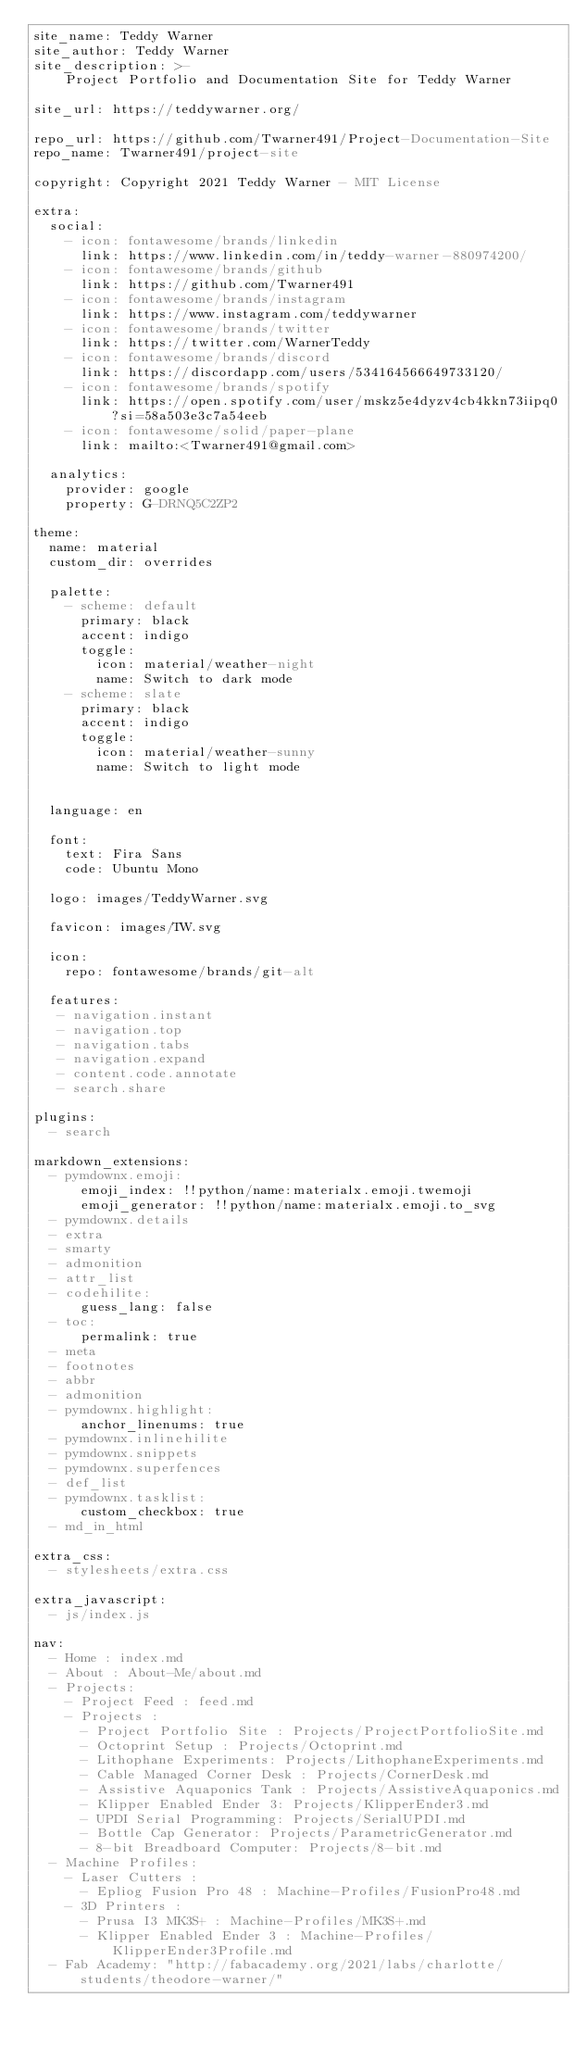Convert code to text. <code><loc_0><loc_0><loc_500><loc_500><_YAML_>site_name: Teddy Warner
site_author: Teddy Warner
site_description: >-
    Project Portfolio and Documentation Site for Teddy Warner

site_url: https://teddywarner.org/

repo_url: https://github.com/Twarner491/Project-Documentation-Site
repo_name: Twarner491/project-site

copyright: Copyright 2021 Teddy Warner - MIT License

extra:
  social:
    - icon: fontawesome/brands/linkedin
      link: https://www.linkedin.com/in/teddy-warner-880974200/
    - icon: fontawesome/brands/github
      link: https://github.com/Twarner491
    - icon: fontawesome/brands/instagram
      link: https://www.instagram.com/teddywarner
    - icon: fontawesome/brands/twitter
      link: https://twitter.com/WarnerTeddy
    - icon: fontawesome/brands/discord
      link: https://discordapp.com/users/534164566649733120/
    - icon: fontawesome/brands/spotify
      link: https://open.spotify.com/user/mskz5e4dyzv4cb4kkn73iipq0?si=58a503e3c7a54eeb
    - icon: fontawesome/solid/paper-plane
      link: mailto:<Twarner491@gmail.com>

  analytics:
    provider: google
    property: G-DRNQ5C2ZP2

theme:
  name: material
  custom_dir: overrides

  palette:
    - scheme: default
      primary: black
      accent: indigo
      toggle:
        icon: material/weather-night
        name: Switch to dark mode
    - scheme: slate
      primary: black
      accent: indigo
      toggle:
        icon: material/weather-sunny
        name: Switch to light mode


  language: en

  font:
    text: Fira Sans
    code: Ubuntu Mono

  logo: images/TeddyWarner.svg

  favicon: images/TW.svg

  icon:
    repo: fontawesome/brands/git-alt
                          
  features:
   - navigation.instant
   - navigation.top
   - navigation.tabs
   - navigation.expand
   - content.code.annotate
   - search.share

plugins:
  - search

markdown_extensions:
  - pymdownx.emoji:
      emoji_index: !!python/name:materialx.emoji.twemoji
      emoji_generator: !!python/name:materialx.emoji.to_svg
  - pymdownx.details
  - extra
  - smarty
  - admonition
  - attr_list
  - codehilite:
      guess_lang: false
  - toc:
      permalink: true
  - meta
  - footnotes
  - abbr
  - admonition
  - pymdownx.highlight:
      anchor_linenums: true
  - pymdownx.inlinehilite
  - pymdownx.snippets
  - pymdownx.superfences
  - def_list
  - pymdownx.tasklist:
      custom_checkbox: true
  - md_in_html

extra_css:
  - stylesheets/extra.css

extra_javascript:
  - js/index.js 

nav:
  - Home : index.md
  - About : About-Me/about.md
  - Projects: 
    - Project Feed : feed.md
    - Projects : 
      - Project Portfolio Site : Projects/ProjectPortfolioSite.md
      - Octoprint Setup : Projects/Octoprint.md
      - Lithophane Experiments: Projects/LithophaneExperiments.md
      - Cable Managed Corner Desk : Projects/CornerDesk.md
      - Assistive Aquaponics Tank : Projects/AssistiveAquaponics.md
      - Klipper Enabled Ender 3: Projects/KlipperEnder3.md
      - UPDI Serial Programming: Projects/SerialUPDI.md
      - Bottle Cap Generator: Projects/ParametricGenerator.md
      - 8-bit Breadboard Computer: Projects/8-bit.md
  - Machine Profiles: 
    - Laser Cutters :
      - Epliog Fusion Pro 48 : Machine-Profiles/FusionPro48.md
    - 3D Printers : 
      - Prusa I3 MK3S+ : Machine-Profiles/MK3S+.md
      - Klipper Enabled Ender 3 : Machine-Profiles/KlipperEnder3Profile.md
  - Fab Academy: "http://fabacademy.org/2021/labs/charlotte/students/theodore-warner/"</code> 